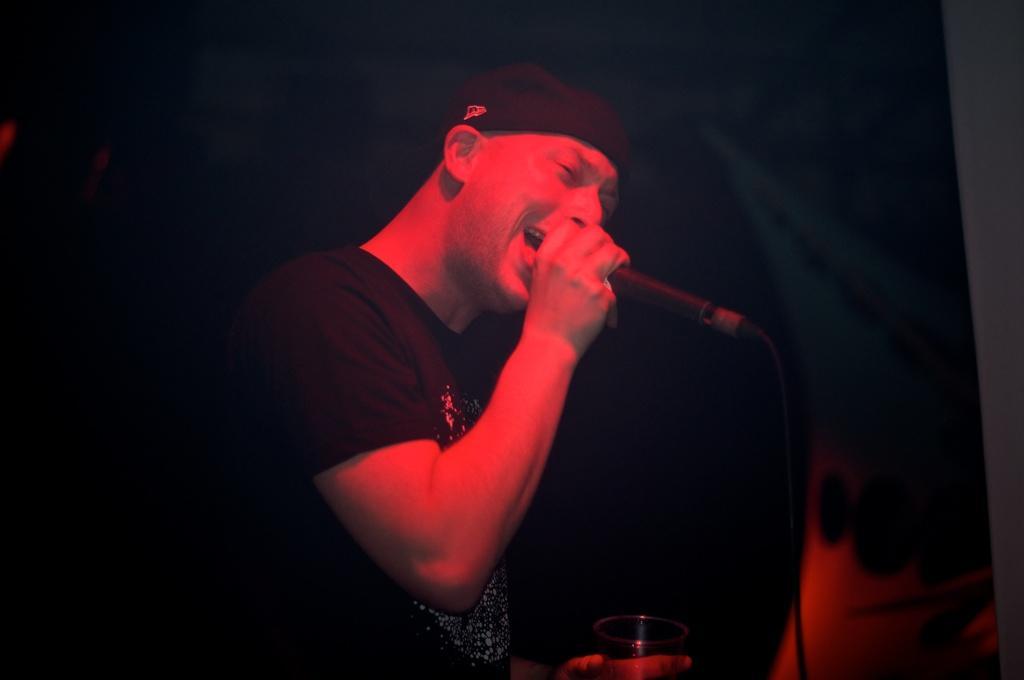Can you describe this image briefly? In the given picture, I can see the person standing, singing, holding a mike after that same person holding a wine glass behind the person i can see a black color. 